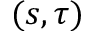Convert formula to latex. <formula><loc_0><loc_0><loc_500><loc_500>( s , \tau )</formula> 